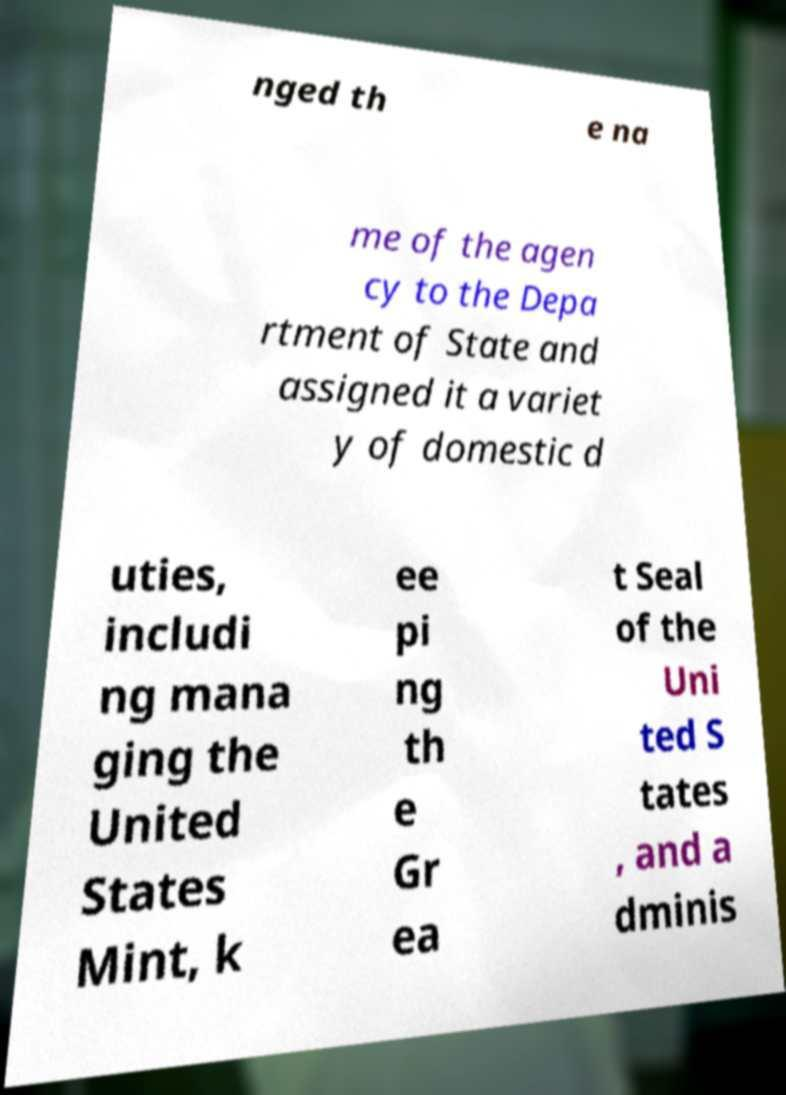Can you accurately transcribe the text from the provided image for me? nged th e na me of the agen cy to the Depa rtment of State and assigned it a variet y of domestic d uties, includi ng mana ging the United States Mint, k ee pi ng th e Gr ea t Seal of the Uni ted S tates , and a dminis 